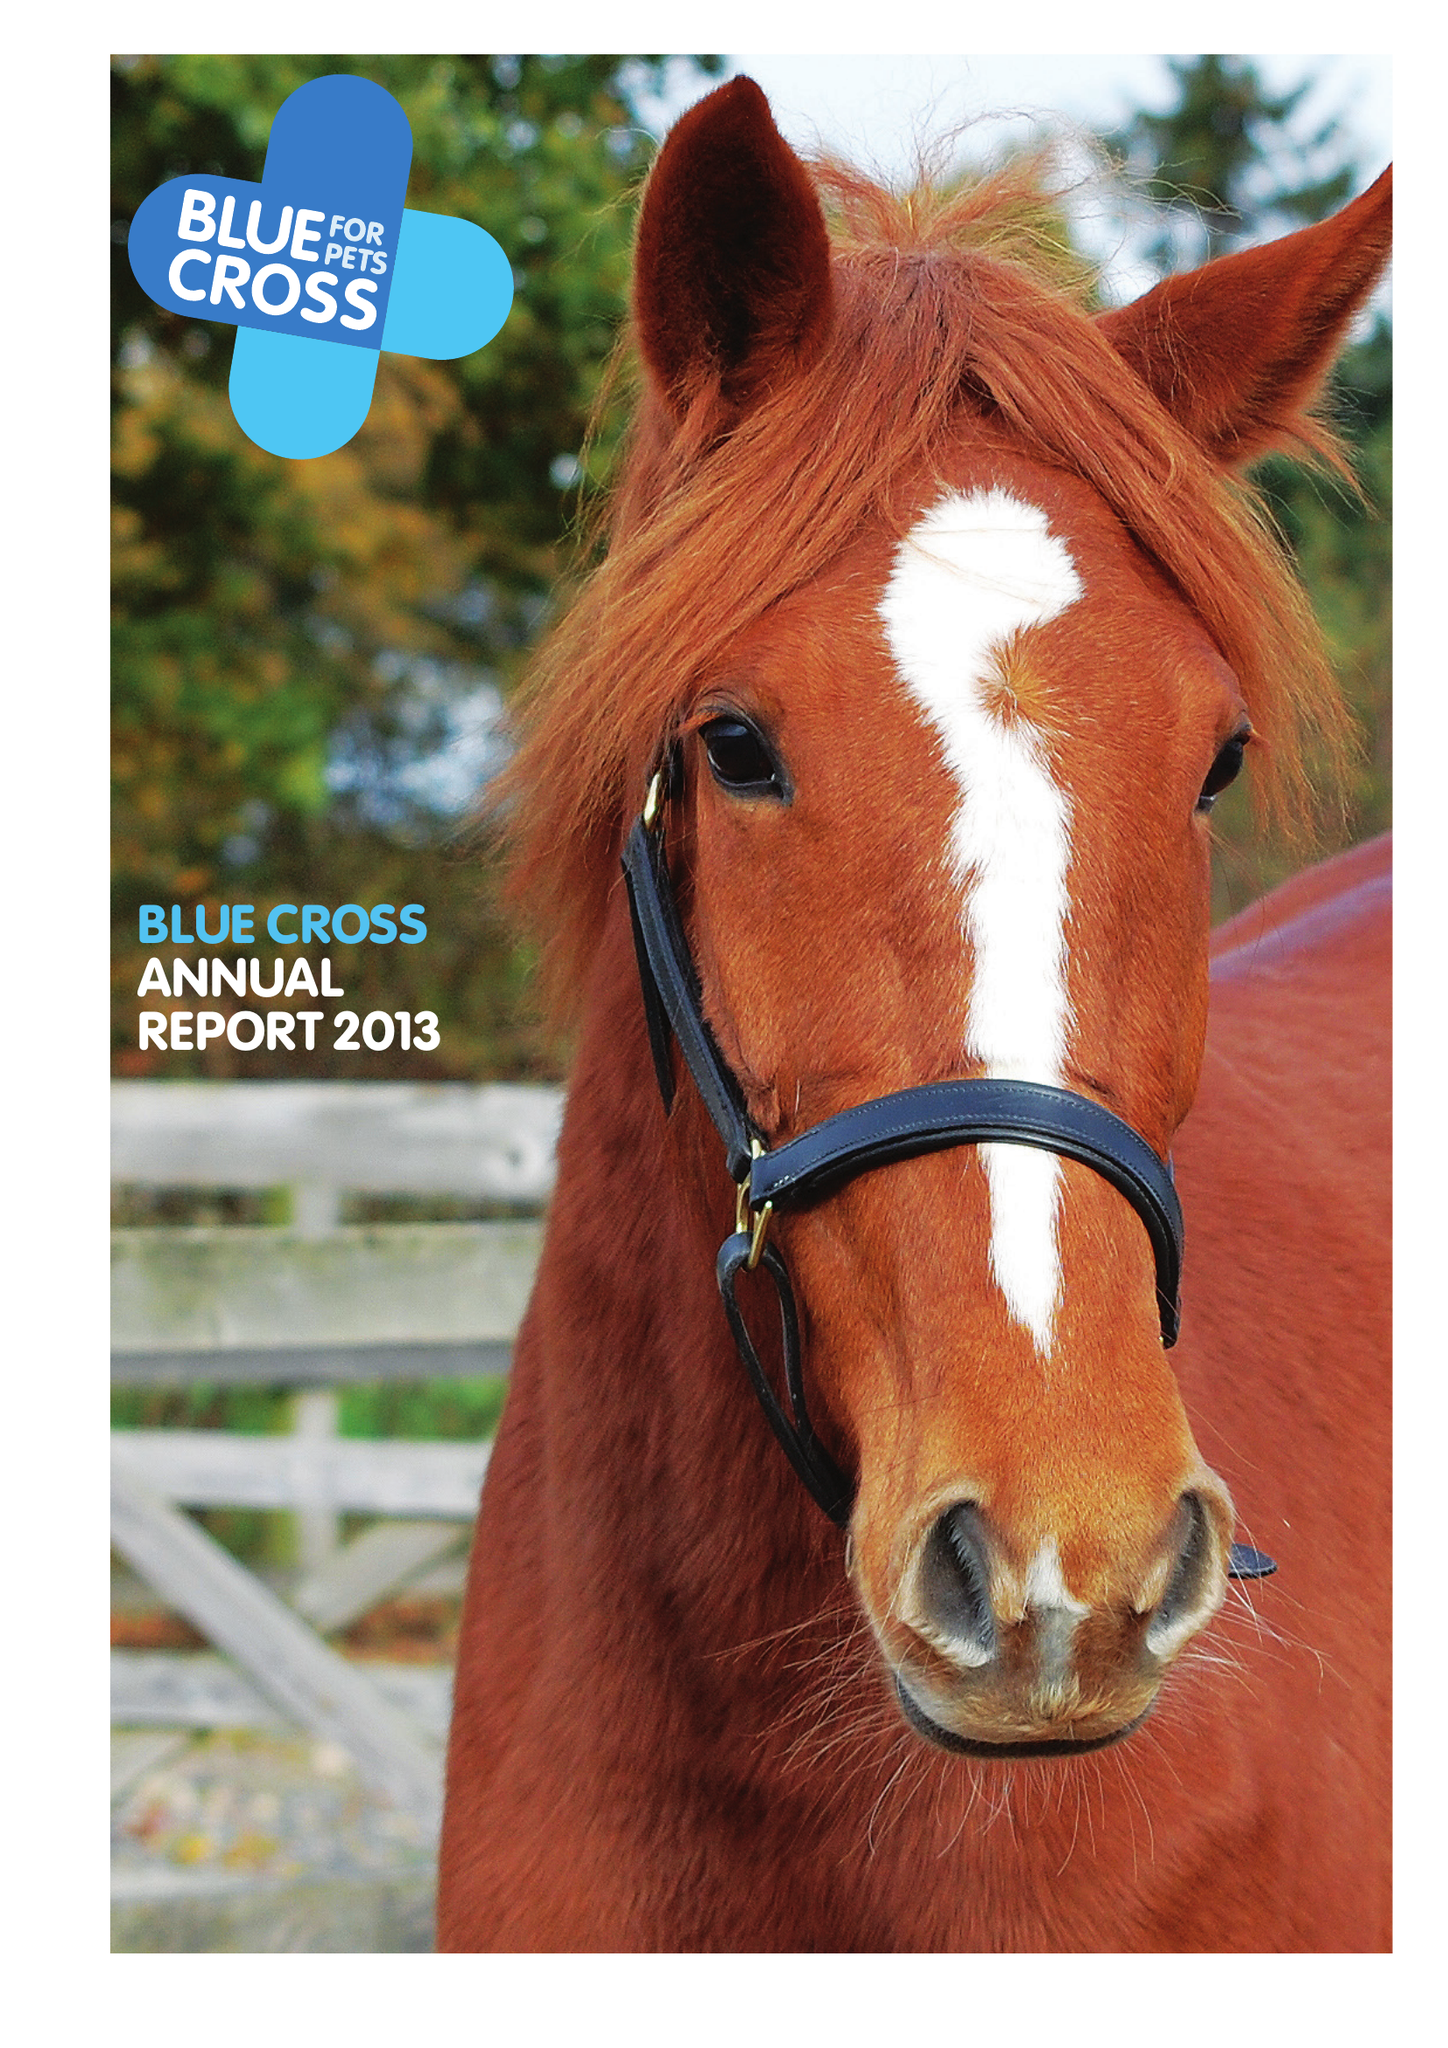What is the value for the address__postcode?
Answer the question using a single word or phrase. OX18 4PF 